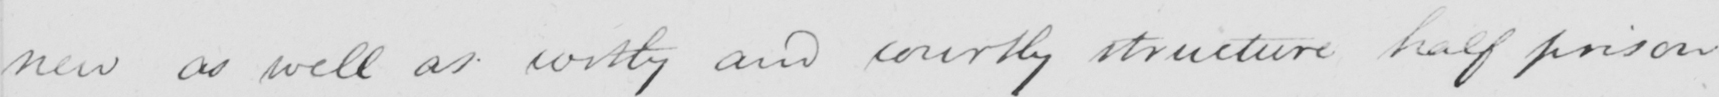What is written in this line of handwriting? new as well as costly and courtly structure half prison 